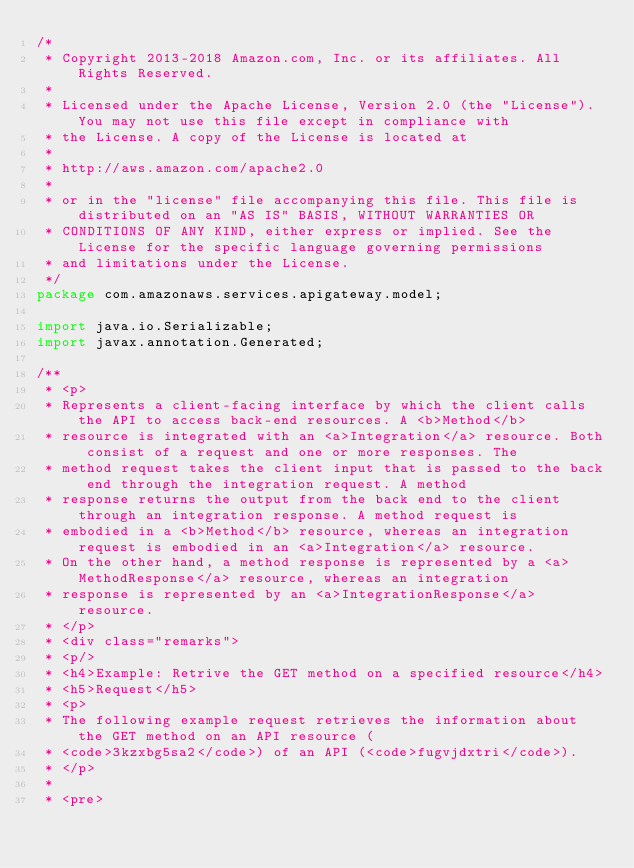Convert code to text. <code><loc_0><loc_0><loc_500><loc_500><_Java_>/*
 * Copyright 2013-2018 Amazon.com, Inc. or its affiliates. All Rights Reserved.
 * 
 * Licensed under the Apache License, Version 2.0 (the "License"). You may not use this file except in compliance with
 * the License. A copy of the License is located at
 * 
 * http://aws.amazon.com/apache2.0
 * 
 * or in the "license" file accompanying this file. This file is distributed on an "AS IS" BASIS, WITHOUT WARRANTIES OR
 * CONDITIONS OF ANY KIND, either express or implied. See the License for the specific language governing permissions
 * and limitations under the License.
 */
package com.amazonaws.services.apigateway.model;

import java.io.Serializable;
import javax.annotation.Generated;

/**
 * <p>
 * Represents a client-facing interface by which the client calls the API to access back-end resources. A <b>Method</b>
 * resource is integrated with an <a>Integration</a> resource. Both consist of a request and one or more responses. The
 * method request takes the client input that is passed to the back end through the integration request. A method
 * response returns the output from the back end to the client through an integration response. A method request is
 * embodied in a <b>Method</b> resource, whereas an integration request is embodied in an <a>Integration</a> resource.
 * On the other hand, a method response is represented by a <a>MethodResponse</a> resource, whereas an integration
 * response is represented by an <a>IntegrationResponse</a> resource.
 * </p>
 * <div class="remarks">
 * <p/>
 * <h4>Example: Retrive the GET method on a specified resource</h4>
 * <h5>Request</h5>
 * <p>
 * The following example request retrieves the information about the GET method on an API resource (
 * <code>3kzxbg5sa2</code>) of an API (<code>fugvjdxtri</code>).
 * </p>
 * 
 * <pre></code> 